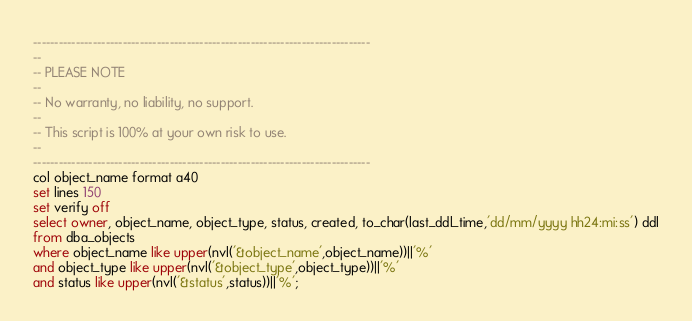<code> <loc_0><loc_0><loc_500><loc_500><_SQL_>-------------------------------------------------------------------------------
--
-- PLEASE NOTE
-- 
-- No warranty, no liability, no support.
--
-- This script is 100% at your own risk to use.
--
-------------------------------------------------------------------------------
col object_name format a40
set lines 150
set verify off
select owner, object_name, object_type, status, created, to_char(last_ddl_time,'dd/mm/yyyy hh24:mi:ss') ddl
from dba_objects
where object_name like upper(nvl('&object_name',object_name))||'%'
and object_type like upper(nvl('&object_type',object_type))||'%'
and status like upper(nvl('&status',status))||'%';
</code> 